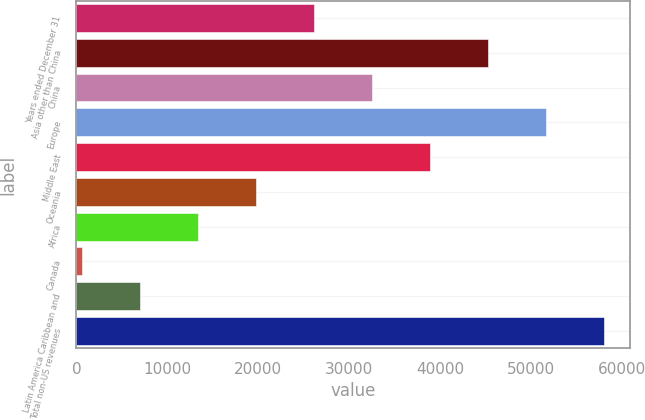Convert chart. <chart><loc_0><loc_0><loc_500><loc_500><bar_chart><fcel>Years ended December 31<fcel>Asia other than China<fcel>China<fcel>Europe<fcel>Middle East<fcel>Oceania<fcel>Africa<fcel>Canada<fcel>Latin America Caribbean and<fcel>Total non-US revenues<nl><fcel>26089.6<fcel>45197.8<fcel>32459<fcel>51567.2<fcel>38828.4<fcel>19720.2<fcel>13350.8<fcel>612<fcel>6981.4<fcel>57936.6<nl></chart> 